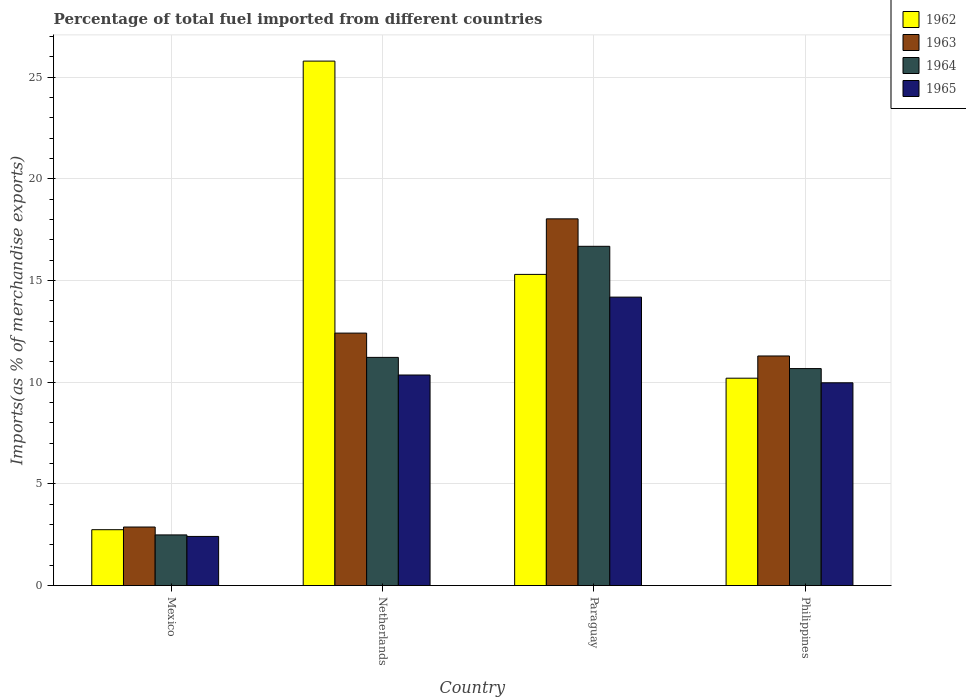How many different coloured bars are there?
Keep it short and to the point. 4. Are the number of bars per tick equal to the number of legend labels?
Provide a short and direct response. Yes. Are the number of bars on each tick of the X-axis equal?
Ensure brevity in your answer.  Yes. How many bars are there on the 4th tick from the left?
Give a very brief answer. 4. How many bars are there on the 4th tick from the right?
Provide a succinct answer. 4. In how many cases, is the number of bars for a given country not equal to the number of legend labels?
Your answer should be very brief. 0. What is the percentage of imports to different countries in 1963 in Mexico?
Your response must be concise. 2.88. Across all countries, what is the maximum percentage of imports to different countries in 1965?
Give a very brief answer. 14.18. Across all countries, what is the minimum percentage of imports to different countries in 1963?
Provide a short and direct response. 2.88. In which country was the percentage of imports to different countries in 1964 maximum?
Keep it short and to the point. Paraguay. In which country was the percentage of imports to different countries in 1963 minimum?
Make the answer very short. Mexico. What is the total percentage of imports to different countries in 1965 in the graph?
Ensure brevity in your answer.  36.92. What is the difference between the percentage of imports to different countries in 1963 in Netherlands and that in Philippines?
Provide a succinct answer. 1.12. What is the difference between the percentage of imports to different countries in 1964 in Paraguay and the percentage of imports to different countries in 1965 in Mexico?
Offer a very short reply. 14.27. What is the average percentage of imports to different countries in 1962 per country?
Offer a terse response. 13.51. What is the difference between the percentage of imports to different countries of/in 1965 and percentage of imports to different countries of/in 1963 in Netherlands?
Your answer should be very brief. -2.06. What is the ratio of the percentage of imports to different countries in 1965 in Mexico to that in Philippines?
Ensure brevity in your answer.  0.24. Is the percentage of imports to different countries in 1962 in Netherlands less than that in Philippines?
Give a very brief answer. No. Is the difference between the percentage of imports to different countries in 1965 in Netherlands and Philippines greater than the difference between the percentage of imports to different countries in 1963 in Netherlands and Philippines?
Offer a terse response. No. What is the difference between the highest and the second highest percentage of imports to different countries in 1964?
Your response must be concise. 6.01. What is the difference between the highest and the lowest percentage of imports to different countries in 1965?
Give a very brief answer. 11.77. In how many countries, is the percentage of imports to different countries in 1964 greater than the average percentage of imports to different countries in 1964 taken over all countries?
Your answer should be very brief. 3. Is it the case that in every country, the sum of the percentage of imports to different countries in 1964 and percentage of imports to different countries in 1963 is greater than the sum of percentage of imports to different countries in 1962 and percentage of imports to different countries in 1965?
Ensure brevity in your answer.  No. What does the 4th bar from the left in Philippines represents?
Your answer should be very brief. 1965. What does the 2nd bar from the right in Paraguay represents?
Offer a terse response. 1964. Is it the case that in every country, the sum of the percentage of imports to different countries in 1965 and percentage of imports to different countries in 1962 is greater than the percentage of imports to different countries in 1964?
Ensure brevity in your answer.  Yes. How many bars are there?
Ensure brevity in your answer.  16. What is the difference between two consecutive major ticks on the Y-axis?
Offer a terse response. 5. Are the values on the major ticks of Y-axis written in scientific E-notation?
Offer a very short reply. No. Does the graph contain any zero values?
Your answer should be very brief. No. What is the title of the graph?
Keep it short and to the point. Percentage of total fuel imported from different countries. What is the label or title of the Y-axis?
Make the answer very short. Imports(as % of merchandise exports). What is the Imports(as % of merchandise exports) in 1962 in Mexico?
Offer a terse response. 2.75. What is the Imports(as % of merchandise exports) of 1963 in Mexico?
Your response must be concise. 2.88. What is the Imports(as % of merchandise exports) of 1964 in Mexico?
Your answer should be compact. 2.49. What is the Imports(as % of merchandise exports) of 1965 in Mexico?
Give a very brief answer. 2.42. What is the Imports(as % of merchandise exports) of 1962 in Netherlands?
Provide a succinct answer. 25.79. What is the Imports(as % of merchandise exports) in 1963 in Netherlands?
Provide a short and direct response. 12.41. What is the Imports(as % of merchandise exports) of 1964 in Netherlands?
Provide a short and direct response. 11.22. What is the Imports(as % of merchandise exports) in 1965 in Netherlands?
Your response must be concise. 10.35. What is the Imports(as % of merchandise exports) in 1962 in Paraguay?
Provide a succinct answer. 15.3. What is the Imports(as % of merchandise exports) of 1963 in Paraguay?
Provide a succinct answer. 18.03. What is the Imports(as % of merchandise exports) of 1964 in Paraguay?
Your answer should be compact. 16.68. What is the Imports(as % of merchandise exports) in 1965 in Paraguay?
Offer a very short reply. 14.18. What is the Imports(as % of merchandise exports) in 1962 in Philippines?
Make the answer very short. 10.2. What is the Imports(as % of merchandise exports) of 1963 in Philippines?
Keep it short and to the point. 11.29. What is the Imports(as % of merchandise exports) in 1964 in Philippines?
Make the answer very short. 10.67. What is the Imports(as % of merchandise exports) in 1965 in Philippines?
Offer a very short reply. 9.97. Across all countries, what is the maximum Imports(as % of merchandise exports) of 1962?
Make the answer very short. 25.79. Across all countries, what is the maximum Imports(as % of merchandise exports) of 1963?
Your answer should be compact. 18.03. Across all countries, what is the maximum Imports(as % of merchandise exports) in 1964?
Your answer should be very brief. 16.68. Across all countries, what is the maximum Imports(as % of merchandise exports) in 1965?
Provide a succinct answer. 14.18. Across all countries, what is the minimum Imports(as % of merchandise exports) in 1962?
Your answer should be very brief. 2.75. Across all countries, what is the minimum Imports(as % of merchandise exports) of 1963?
Your answer should be compact. 2.88. Across all countries, what is the minimum Imports(as % of merchandise exports) of 1964?
Your answer should be compact. 2.49. Across all countries, what is the minimum Imports(as % of merchandise exports) in 1965?
Make the answer very short. 2.42. What is the total Imports(as % of merchandise exports) of 1962 in the graph?
Provide a succinct answer. 54.03. What is the total Imports(as % of merchandise exports) in 1963 in the graph?
Make the answer very short. 44.61. What is the total Imports(as % of merchandise exports) of 1964 in the graph?
Provide a succinct answer. 41.06. What is the total Imports(as % of merchandise exports) in 1965 in the graph?
Make the answer very short. 36.92. What is the difference between the Imports(as % of merchandise exports) of 1962 in Mexico and that in Netherlands?
Offer a very short reply. -23.04. What is the difference between the Imports(as % of merchandise exports) of 1963 in Mexico and that in Netherlands?
Your response must be concise. -9.53. What is the difference between the Imports(as % of merchandise exports) in 1964 in Mexico and that in Netherlands?
Offer a terse response. -8.73. What is the difference between the Imports(as % of merchandise exports) of 1965 in Mexico and that in Netherlands?
Offer a terse response. -7.94. What is the difference between the Imports(as % of merchandise exports) of 1962 in Mexico and that in Paraguay?
Provide a succinct answer. -12.55. What is the difference between the Imports(as % of merchandise exports) in 1963 in Mexico and that in Paraguay?
Make the answer very short. -15.15. What is the difference between the Imports(as % of merchandise exports) of 1964 in Mexico and that in Paraguay?
Provide a succinct answer. -14.19. What is the difference between the Imports(as % of merchandise exports) of 1965 in Mexico and that in Paraguay?
Offer a terse response. -11.77. What is the difference between the Imports(as % of merchandise exports) in 1962 in Mexico and that in Philippines?
Your response must be concise. -7.45. What is the difference between the Imports(as % of merchandise exports) of 1963 in Mexico and that in Philippines?
Make the answer very short. -8.41. What is the difference between the Imports(as % of merchandise exports) in 1964 in Mexico and that in Philippines?
Your answer should be compact. -8.18. What is the difference between the Imports(as % of merchandise exports) of 1965 in Mexico and that in Philippines?
Your answer should be very brief. -7.55. What is the difference between the Imports(as % of merchandise exports) of 1962 in Netherlands and that in Paraguay?
Ensure brevity in your answer.  10.49. What is the difference between the Imports(as % of merchandise exports) of 1963 in Netherlands and that in Paraguay?
Offer a very short reply. -5.62. What is the difference between the Imports(as % of merchandise exports) in 1964 in Netherlands and that in Paraguay?
Give a very brief answer. -5.46. What is the difference between the Imports(as % of merchandise exports) in 1965 in Netherlands and that in Paraguay?
Your answer should be very brief. -3.83. What is the difference between the Imports(as % of merchandise exports) in 1962 in Netherlands and that in Philippines?
Your answer should be compact. 15.59. What is the difference between the Imports(as % of merchandise exports) in 1963 in Netherlands and that in Philippines?
Your answer should be very brief. 1.12. What is the difference between the Imports(as % of merchandise exports) of 1964 in Netherlands and that in Philippines?
Offer a terse response. 0.55. What is the difference between the Imports(as % of merchandise exports) in 1965 in Netherlands and that in Philippines?
Ensure brevity in your answer.  0.38. What is the difference between the Imports(as % of merchandise exports) of 1962 in Paraguay and that in Philippines?
Your response must be concise. 5.1. What is the difference between the Imports(as % of merchandise exports) of 1963 in Paraguay and that in Philippines?
Make the answer very short. 6.74. What is the difference between the Imports(as % of merchandise exports) in 1964 in Paraguay and that in Philippines?
Your response must be concise. 6.01. What is the difference between the Imports(as % of merchandise exports) of 1965 in Paraguay and that in Philippines?
Ensure brevity in your answer.  4.21. What is the difference between the Imports(as % of merchandise exports) of 1962 in Mexico and the Imports(as % of merchandise exports) of 1963 in Netherlands?
Give a very brief answer. -9.67. What is the difference between the Imports(as % of merchandise exports) in 1962 in Mexico and the Imports(as % of merchandise exports) in 1964 in Netherlands?
Make the answer very short. -8.47. What is the difference between the Imports(as % of merchandise exports) in 1962 in Mexico and the Imports(as % of merchandise exports) in 1965 in Netherlands?
Offer a terse response. -7.61. What is the difference between the Imports(as % of merchandise exports) in 1963 in Mexico and the Imports(as % of merchandise exports) in 1964 in Netherlands?
Keep it short and to the point. -8.34. What is the difference between the Imports(as % of merchandise exports) in 1963 in Mexico and the Imports(as % of merchandise exports) in 1965 in Netherlands?
Offer a very short reply. -7.47. What is the difference between the Imports(as % of merchandise exports) of 1964 in Mexico and the Imports(as % of merchandise exports) of 1965 in Netherlands?
Your response must be concise. -7.86. What is the difference between the Imports(as % of merchandise exports) in 1962 in Mexico and the Imports(as % of merchandise exports) in 1963 in Paraguay?
Provide a short and direct response. -15.28. What is the difference between the Imports(as % of merchandise exports) of 1962 in Mexico and the Imports(as % of merchandise exports) of 1964 in Paraguay?
Give a very brief answer. -13.93. What is the difference between the Imports(as % of merchandise exports) in 1962 in Mexico and the Imports(as % of merchandise exports) in 1965 in Paraguay?
Your answer should be compact. -11.44. What is the difference between the Imports(as % of merchandise exports) in 1963 in Mexico and the Imports(as % of merchandise exports) in 1964 in Paraguay?
Give a very brief answer. -13.8. What is the difference between the Imports(as % of merchandise exports) of 1963 in Mexico and the Imports(as % of merchandise exports) of 1965 in Paraguay?
Offer a very short reply. -11.3. What is the difference between the Imports(as % of merchandise exports) of 1964 in Mexico and the Imports(as % of merchandise exports) of 1965 in Paraguay?
Your answer should be very brief. -11.69. What is the difference between the Imports(as % of merchandise exports) of 1962 in Mexico and the Imports(as % of merchandise exports) of 1963 in Philippines?
Your answer should be compact. -8.54. What is the difference between the Imports(as % of merchandise exports) in 1962 in Mexico and the Imports(as % of merchandise exports) in 1964 in Philippines?
Your answer should be very brief. -7.92. What is the difference between the Imports(as % of merchandise exports) in 1962 in Mexico and the Imports(as % of merchandise exports) in 1965 in Philippines?
Offer a terse response. -7.22. What is the difference between the Imports(as % of merchandise exports) in 1963 in Mexico and the Imports(as % of merchandise exports) in 1964 in Philippines?
Your answer should be compact. -7.79. What is the difference between the Imports(as % of merchandise exports) in 1963 in Mexico and the Imports(as % of merchandise exports) in 1965 in Philippines?
Your answer should be very brief. -7.09. What is the difference between the Imports(as % of merchandise exports) in 1964 in Mexico and the Imports(as % of merchandise exports) in 1965 in Philippines?
Offer a very short reply. -7.48. What is the difference between the Imports(as % of merchandise exports) of 1962 in Netherlands and the Imports(as % of merchandise exports) of 1963 in Paraguay?
Your answer should be very brief. 7.76. What is the difference between the Imports(as % of merchandise exports) of 1962 in Netherlands and the Imports(as % of merchandise exports) of 1964 in Paraguay?
Keep it short and to the point. 9.11. What is the difference between the Imports(as % of merchandise exports) of 1962 in Netherlands and the Imports(as % of merchandise exports) of 1965 in Paraguay?
Give a very brief answer. 11.6. What is the difference between the Imports(as % of merchandise exports) in 1963 in Netherlands and the Imports(as % of merchandise exports) in 1964 in Paraguay?
Keep it short and to the point. -4.27. What is the difference between the Imports(as % of merchandise exports) of 1963 in Netherlands and the Imports(as % of merchandise exports) of 1965 in Paraguay?
Keep it short and to the point. -1.77. What is the difference between the Imports(as % of merchandise exports) in 1964 in Netherlands and the Imports(as % of merchandise exports) in 1965 in Paraguay?
Your answer should be very brief. -2.96. What is the difference between the Imports(as % of merchandise exports) in 1962 in Netherlands and the Imports(as % of merchandise exports) in 1963 in Philippines?
Provide a short and direct response. 14.5. What is the difference between the Imports(as % of merchandise exports) in 1962 in Netherlands and the Imports(as % of merchandise exports) in 1964 in Philippines?
Offer a very short reply. 15.12. What is the difference between the Imports(as % of merchandise exports) in 1962 in Netherlands and the Imports(as % of merchandise exports) in 1965 in Philippines?
Offer a terse response. 15.82. What is the difference between the Imports(as % of merchandise exports) in 1963 in Netherlands and the Imports(as % of merchandise exports) in 1964 in Philippines?
Your response must be concise. 1.74. What is the difference between the Imports(as % of merchandise exports) in 1963 in Netherlands and the Imports(as % of merchandise exports) in 1965 in Philippines?
Give a very brief answer. 2.44. What is the difference between the Imports(as % of merchandise exports) in 1964 in Netherlands and the Imports(as % of merchandise exports) in 1965 in Philippines?
Your answer should be compact. 1.25. What is the difference between the Imports(as % of merchandise exports) in 1962 in Paraguay and the Imports(as % of merchandise exports) in 1963 in Philippines?
Give a very brief answer. 4.01. What is the difference between the Imports(as % of merchandise exports) of 1962 in Paraguay and the Imports(as % of merchandise exports) of 1964 in Philippines?
Ensure brevity in your answer.  4.63. What is the difference between the Imports(as % of merchandise exports) of 1962 in Paraguay and the Imports(as % of merchandise exports) of 1965 in Philippines?
Make the answer very short. 5.33. What is the difference between the Imports(as % of merchandise exports) of 1963 in Paraguay and the Imports(as % of merchandise exports) of 1964 in Philippines?
Offer a terse response. 7.36. What is the difference between the Imports(as % of merchandise exports) of 1963 in Paraguay and the Imports(as % of merchandise exports) of 1965 in Philippines?
Provide a short and direct response. 8.06. What is the difference between the Imports(as % of merchandise exports) of 1964 in Paraguay and the Imports(as % of merchandise exports) of 1965 in Philippines?
Your answer should be compact. 6.71. What is the average Imports(as % of merchandise exports) of 1962 per country?
Your answer should be compact. 13.51. What is the average Imports(as % of merchandise exports) in 1963 per country?
Give a very brief answer. 11.15. What is the average Imports(as % of merchandise exports) of 1964 per country?
Your answer should be compact. 10.26. What is the average Imports(as % of merchandise exports) in 1965 per country?
Give a very brief answer. 9.23. What is the difference between the Imports(as % of merchandise exports) in 1962 and Imports(as % of merchandise exports) in 1963 in Mexico?
Your answer should be compact. -0.13. What is the difference between the Imports(as % of merchandise exports) of 1962 and Imports(as % of merchandise exports) of 1964 in Mexico?
Ensure brevity in your answer.  0.26. What is the difference between the Imports(as % of merchandise exports) of 1962 and Imports(as % of merchandise exports) of 1965 in Mexico?
Provide a short and direct response. 0.33. What is the difference between the Imports(as % of merchandise exports) in 1963 and Imports(as % of merchandise exports) in 1964 in Mexico?
Give a very brief answer. 0.39. What is the difference between the Imports(as % of merchandise exports) of 1963 and Imports(as % of merchandise exports) of 1965 in Mexico?
Give a very brief answer. 0.46. What is the difference between the Imports(as % of merchandise exports) in 1964 and Imports(as % of merchandise exports) in 1965 in Mexico?
Offer a terse response. 0.07. What is the difference between the Imports(as % of merchandise exports) in 1962 and Imports(as % of merchandise exports) in 1963 in Netherlands?
Your response must be concise. 13.37. What is the difference between the Imports(as % of merchandise exports) of 1962 and Imports(as % of merchandise exports) of 1964 in Netherlands?
Offer a terse response. 14.57. What is the difference between the Imports(as % of merchandise exports) in 1962 and Imports(as % of merchandise exports) in 1965 in Netherlands?
Offer a terse response. 15.43. What is the difference between the Imports(as % of merchandise exports) of 1963 and Imports(as % of merchandise exports) of 1964 in Netherlands?
Your response must be concise. 1.19. What is the difference between the Imports(as % of merchandise exports) of 1963 and Imports(as % of merchandise exports) of 1965 in Netherlands?
Offer a very short reply. 2.06. What is the difference between the Imports(as % of merchandise exports) in 1964 and Imports(as % of merchandise exports) in 1965 in Netherlands?
Keep it short and to the point. 0.87. What is the difference between the Imports(as % of merchandise exports) in 1962 and Imports(as % of merchandise exports) in 1963 in Paraguay?
Make the answer very short. -2.73. What is the difference between the Imports(as % of merchandise exports) in 1962 and Imports(as % of merchandise exports) in 1964 in Paraguay?
Make the answer very short. -1.38. What is the difference between the Imports(as % of merchandise exports) of 1962 and Imports(as % of merchandise exports) of 1965 in Paraguay?
Ensure brevity in your answer.  1.12. What is the difference between the Imports(as % of merchandise exports) of 1963 and Imports(as % of merchandise exports) of 1964 in Paraguay?
Ensure brevity in your answer.  1.35. What is the difference between the Imports(as % of merchandise exports) of 1963 and Imports(as % of merchandise exports) of 1965 in Paraguay?
Your answer should be very brief. 3.85. What is the difference between the Imports(as % of merchandise exports) of 1964 and Imports(as % of merchandise exports) of 1965 in Paraguay?
Ensure brevity in your answer.  2.5. What is the difference between the Imports(as % of merchandise exports) of 1962 and Imports(as % of merchandise exports) of 1963 in Philippines?
Your answer should be compact. -1.09. What is the difference between the Imports(as % of merchandise exports) of 1962 and Imports(as % of merchandise exports) of 1964 in Philippines?
Make the answer very short. -0.47. What is the difference between the Imports(as % of merchandise exports) of 1962 and Imports(as % of merchandise exports) of 1965 in Philippines?
Provide a succinct answer. 0.23. What is the difference between the Imports(as % of merchandise exports) of 1963 and Imports(as % of merchandise exports) of 1964 in Philippines?
Provide a succinct answer. 0.62. What is the difference between the Imports(as % of merchandise exports) of 1963 and Imports(as % of merchandise exports) of 1965 in Philippines?
Make the answer very short. 1.32. What is the difference between the Imports(as % of merchandise exports) in 1964 and Imports(as % of merchandise exports) in 1965 in Philippines?
Make the answer very short. 0.7. What is the ratio of the Imports(as % of merchandise exports) of 1962 in Mexico to that in Netherlands?
Keep it short and to the point. 0.11. What is the ratio of the Imports(as % of merchandise exports) in 1963 in Mexico to that in Netherlands?
Make the answer very short. 0.23. What is the ratio of the Imports(as % of merchandise exports) in 1964 in Mexico to that in Netherlands?
Give a very brief answer. 0.22. What is the ratio of the Imports(as % of merchandise exports) of 1965 in Mexico to that in Netherlands?
Your response must be concise. 0.23. What is the ratio of the Imports(as % of merchandise exports) in 1962 in Mexico to that in Paraguay?
Ensure brevity in your answer.  0.18. What is the ratio of the Imports(as % of merchandise exports) of 1963 in Mexico to that in Paraguay?
Make the answer very short. 0.16. What is the ratio of the Imports(as % of merchandise exports) of 1964 in Mexico to that in Paraguay?
Your response must be concise. 0.15. What is the ratio of the Imports(as % of merchandise exports) in 1965 in Mexico to that in Paraguay?
Give a very brief answer. 0.17. What is the ratio of the Imports(as % of merchandise exports) in 1962 in Mexico to that in Philippines?
Your answer should be very brief. 0.27. What is the ratio of the Imports(as % of merchandise exports) in 1963 in Mexico to that in Philippines?
Offer a terse response. 0.26. What is the ratio of the Imports(as % of merchandise exports) of 1964 in Mexico to that in Philippines?
Make the answer very short. 0.23. What is the ratio of the Imports(as % of merchandise exports) of 1965 in Mexico to that in Philippines?
Your answer should be very brief. 0.24. What is the ratio of the Imports(as % of merchandise exports) in 1962 in Netherlands to that in Paraguay?
Your answer should be compact. 1.69. What is the ratio of the Imports(as % of merchandise exports) in 1963 in Netherlands to that in Paraguay?
Your answer should be very brief. 0.69. What is the ratio of the Imports(as % of merchandise exports) of 1964 in Netherlands to that in Paraguay?
Your response must be concise. 0.67. What is the ratio of the Imports(as % of merchandise exports) in 1965 in Netherlands to that in Paraguay?
Keep it short and to the point. 0.73. What is the ratio of the Imports(as % of merchandise exports) of 1962 in Netherlands to that in Philippines?
Offer a terse response. 2.53. What is the ratio of the Imports(as % of merchandise exports) of 1963 in Netherlands to that in Philippines?
Your response must be concise. 1.1. What is the ratio of the Imports(as % of merchandise exports) in 1964 in Netherlands to that in Philippines?
Provide a succinct answer. 1.05. What is the ratio of the Imports(as % of merchandise exports) in 1965 in Netherlands to that in Philippines?
Provide a succinct answer. 1.04. What is the ratio of the Imports(as % of merchandise exports) of 1962 in Paraguay to that in Philippines?
Ensure brevity in your answer.  1.5. What is the ratio of the Imports(as % of merchandise exports) of 1963 in Paraguay to that in Philippines?
Offer a terse response. 1.6. What is the ratio of the Imports(as % of merchandise exports) in 1964 in Paraguay to that in Philippines?
Provide a short and direct response. 1.56. What is the ratio of the Imports(as % of merchandise exports) in 1965 in Paraguay to that in Philippines?
Your response must be concise. 1.42. What is the difference between the highest and the second highest Imports(as % of merchandise exports) of 1962?
Your answer should be very brief. 10.49. What is the difference between the highest and the second highest Imports(as % of merchandise exports) in 1963?
Your answer should be compact. 5.62. What is the difference between the highest and the second highest Imports(as % of merchandise exports) in 1964?
Offer a terse response. 5.46. What is the difference between the highest and the second highest Imports(as % of merchandise exports) in 1965?
Offer a terse response. 3.83. What is the difference between the highest and the lowest Imports(as % of merchandise exports) of 1962?
Your answer should be very brief. 23.04. What is the difference between the highest and the lowest Imports(as % of merchandise exports) in 1963?
Provide a short and direct response. 15.15. What is the difference between the highest and the lowest Imports(as % of merchandise exports) in 1964?
Offer a terse response. 14.19. What is the difference between the highest and the lowest Imports(as % of merchandise exports) of 1965?
Your answer should be very brief. 11.77. 